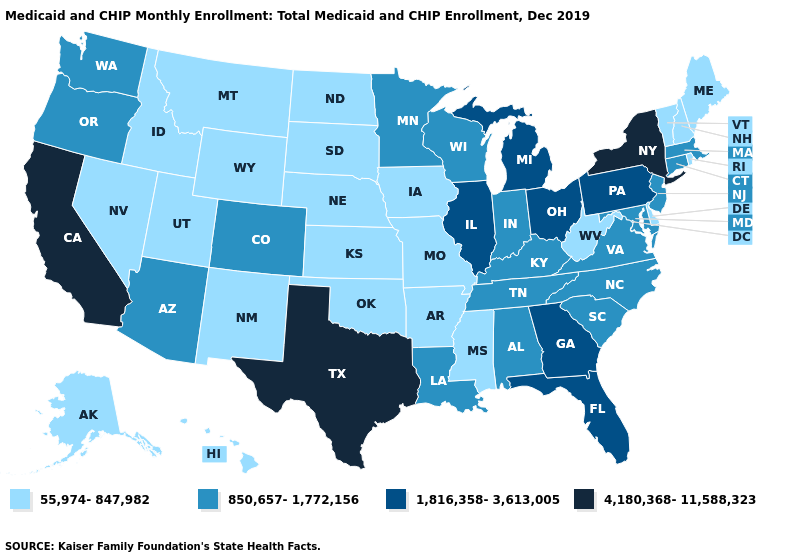Does California have the highest value in the West?
Concise answer only. Yes. What is the lowest value in states that border Virginia?
Be succinct. 55,974-847,982. Name the states that have a value in the range 1,816,358-3,613,005?
Give a very brief answer. Florida, Georgia, Illinois, Michigan, Ohio, Pennsylvania. Which states have the highest value in the USA?
Concise answer only. California, New York, Texas. Which states hav the highest value in the West?
Concise answer only. California. Name the states that have a value in the range 4,180,368-11,588,323?
Give a very brief answer. California, New York, Texas. Does Illinois have a lower value than Arizona?
Write a very short answer. No. Which states have the lowest value in the USA?
Be succinct. Alaska, Arkansas, Delaware, Hawaii, Idaho, Iowa, Kansas, Maine, Mississippi, Missouri, Montana, Nebraska, Nevada, New Hampshire, New Mexico, North Dakota, Oklahoma, Rhode Island, South Dakota, Utah, Vermont, West Virginia, Wyoming. Does the first symbol in the legend represent the smallest category?
Answer briefly. Yes. What is the lowest value in the USA?
Quick response, please. 55,974-847,982. Which states have the lowest value in the USA?
Short answer required. Alaska, Arkansas, Delaware, Hawaii, Idaho, Iowa, Kansas, Maine, Mississippi, Missouri, Montana, Nebraska, Nevada, New Hampshire, New Mexico, North Dakota, Oklahoma, Rhode Island, South Dakota, Utah, Vermont, West Virginia, Wyoming. Name the states that have a value in the range 1,816,358-3,613,005?
Give a very brief answer. Florida, Georgia, Illinois, Michigan, Ohio, Pennsylvania. Does California have the same value as Nebraska?
Give a very brief answer. No. Among the states that border South Dakota , does Minnesota have the lowest value?
Be succinct. No. Does Texas have the highest value in the USA?
Keep it brief. Yes. 